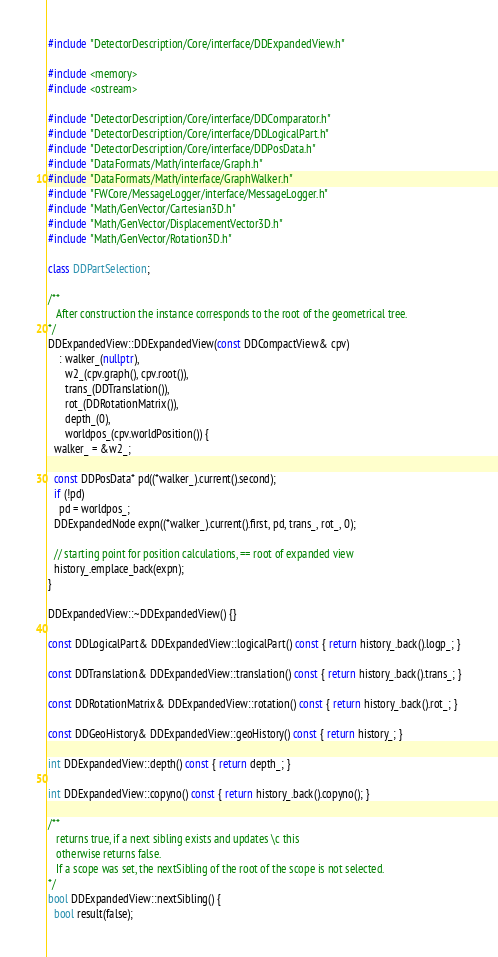<code> <loc_0><loc_0><loc_500><loc_500><_C++_>#include "DetectorDescription/Core/interface/DDExpandedView.h"

#include <memory>
#include <ostream>

#include "DetectorDescription/Core/interface/DDComparator.h"
#include "DetectorDescription/Core/interface/DDLogicalPart.h"
#include "DetectorDescription/Core/interface/DDPosData.h"
#include "DataFormats/Math/interface/Graph.h"
#include "DataFormats/Math/interface/GraphWalker.h"
#include "FWCore/MessageLogger/interface/MessageLogger.h"
#include "Math/GenVector/Cartesian3D.h"
#include "Math/GenVector/DisplacementVector3D.h"
#include "Math/GenVector/Rotation3D.h"

class DDPartSelection;

/** 
   After construction the instance corresponds to the root of the geometrical tree.
*/
DDExpandedView::DDExpandedView(const DDCompactView& cpv)
    : walker_(nullptr),
      w2_(cpv.graph(), cpv.root()),
      trans_(DDTranslation()),
      rot_(DDRotationMatrix()),
      depth_(0),
      worldpos_(cpv.worldPosition()) {
  walker_ = &w2_;

  const DDPosData* pd((*walker_).current().second);
  if (!pd)
    pd = worldpos_;
  DDExpandedNode expn((*walker_).current().first, pd, trans_, rot_, 0);

  // starting point for position calculations, == root of expanded view
  history_.emplace_back(expn);
}

DDExpandedView::~DDExpandedView() {}

const DDLogicalPart& DDExpandedView::logicalPart() const { return history_.back().logp_; }

const DDTranslation& DDExpandedView::translation() const { return history_.back().trans_; }

const DDRotationMatrix& DDExpandedView::rotation() const { return history_.back().rot_; }

const DDGeoHistory& DDExpandedView::geoHistory() const { return history_; }

int DDExpandedView::depth() const { return depth_; }

int DDExpandedView::copyno() const { return history_.back().copyno(); }

/** 
   returns true, if a next sibling exists and updates \c this
   otherwise returns false.
   If a scope was set, the nextSibling of the root of the scope is not selected.
*/
bool DDExpandedView::nextSibling() {
  bool result(false);</code> 